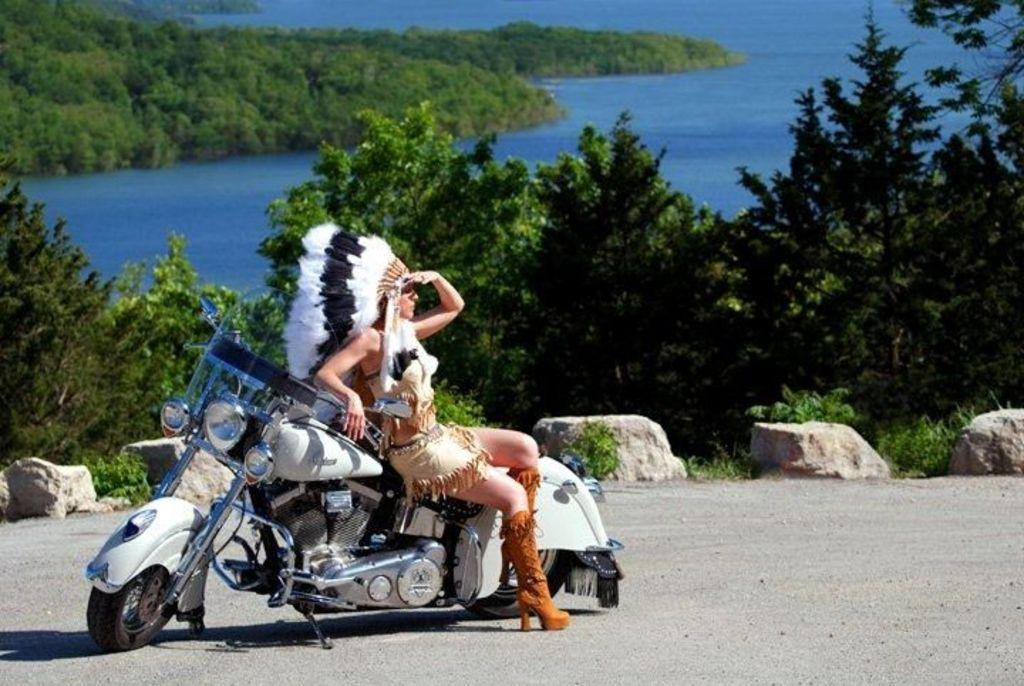Who is the main subject in the image? There is a woman in the image. What is the woman doing in the image? The woman is sitting on a bike. What can be seen in the background of the image? There is a tree and water visible in the background of the image. What type of popcorn is being sold near the woman in the image? There is no popcorn or any indication of a sale in the image. 